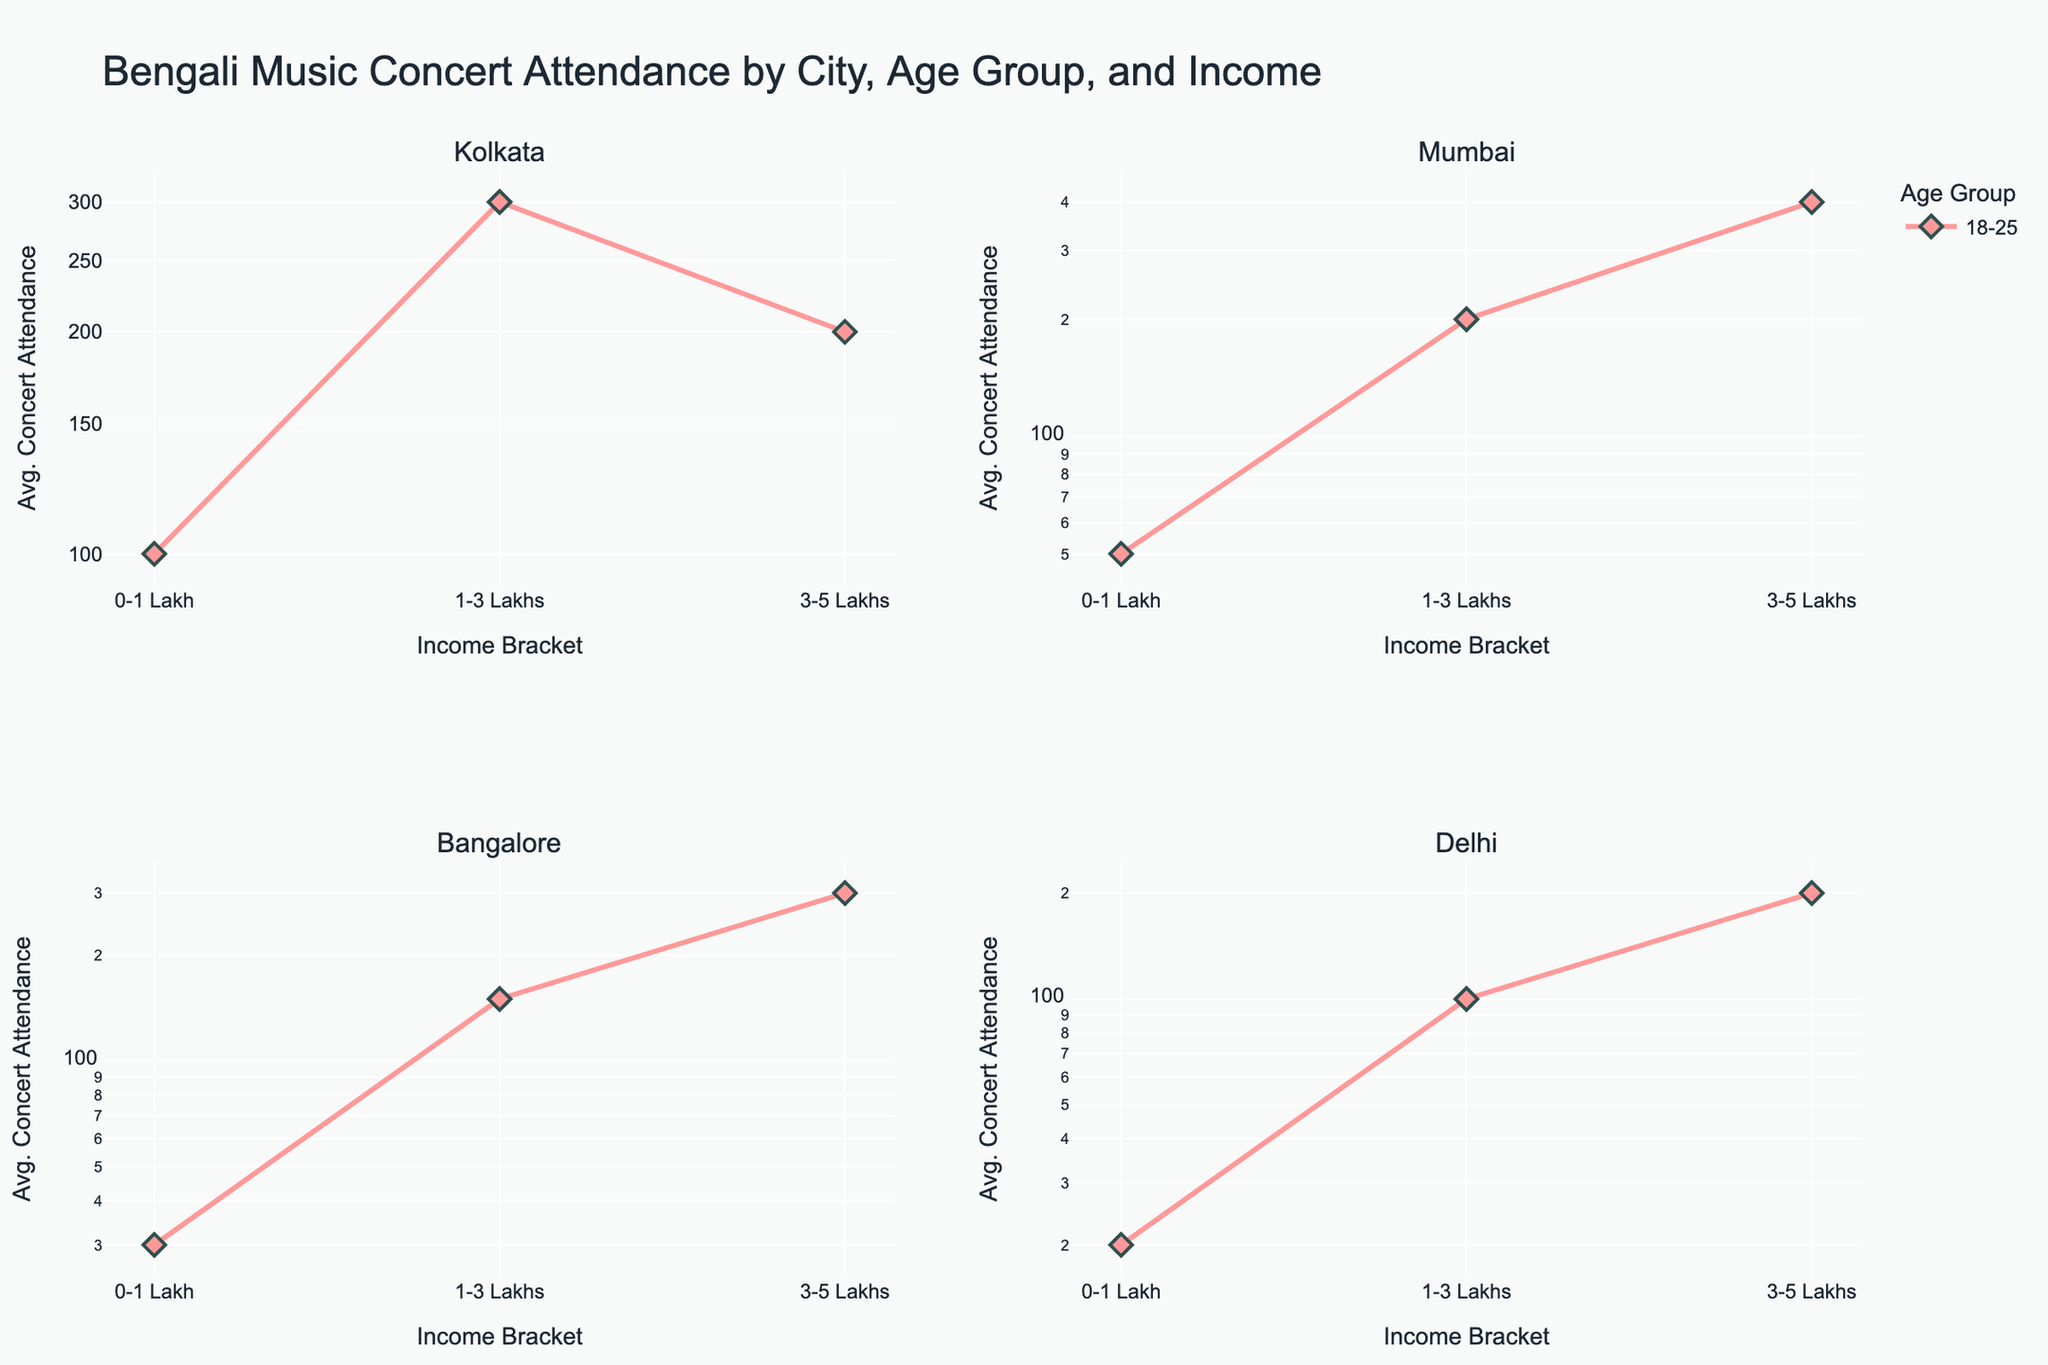What is the title of the figure? The title is usually prominently displayed at the top of the figure. In this case, it states the overall context of the plot.
Answer: Bengali Music Concert Attendance by City, Age Group, and Income What are the income brackets shown on the x-axes? The x-axis denotes different income brackets, which are categorized and labeled clearly.
Answer: 0-1 Lakh, 1-3 Lakhs, 3-5 Lakhs How many age groups are represented in each subplot? Each subplot shows markers and lines for different age groups, indicated by various colors and symbols. You can count the distinct legend entries to determine the number of age groups.
Answer: Four age groups (18-25, 26-35, 36-45, 46-60) Which city has the highest average concert attendance for the 26-35 age group in the 3-5 Lakhs income bracket? Look at the plot for each city. Identify the subplot for 26-35 age group and find the highest marker in the 3-5 Lakhs income bracket.
Answer: Mumbai How does average concert attendance for the 18-25 age group change as income increases in Kolkata? Analyze the line connecting markers in Kolkata's subplot for the 18-25 age group from 0-1 Lakh to 3-5 Lakhs.
Answer: It increases from 100 to 300 and then decreases to 200 Compare the average concert attendance of the 36-45 age group in the 0-1 Lakh income bracket between Bangalore and Delhi. Which city has higher attendance? Examine both Bangalore and Delhi subplots. Identify the values for the 36-45 age group in the 0-1 Lakh income bracket and compare them.
Answer: Bangalore has higher attendance What trend can be observed for the 46-60 age group in Delhi with respect to income brackets? Observe the line and markers in Delhi's subplot for the 46-60 age group across all income brackets.
Answer: Attendance increases with income Which age group in Mumbai shows the most significant increase in concert attendance from the lowest to the highest income bracket? Look at the lines in the Mumbai subplot representing different age groups. Identify the group with the steepest incline from 0-1 Lakh to 3-5 Lakhs.
Answer: 26-35 age group Identify the age group and city where concert attendance is consistently the highest across all income brackets. Analyze each subplot to see which age group consistently shows the highest points across all income brackets for each city.
Answer: 26-35 in Mumbai Which age group and income bracket combination has the lowest average concert attendance across all cities? Compare values in all subplots across all age groups and income brackets to find the lowest attendance.
Answer: 46-60 age group with 0-1 Lakh in Delhi 